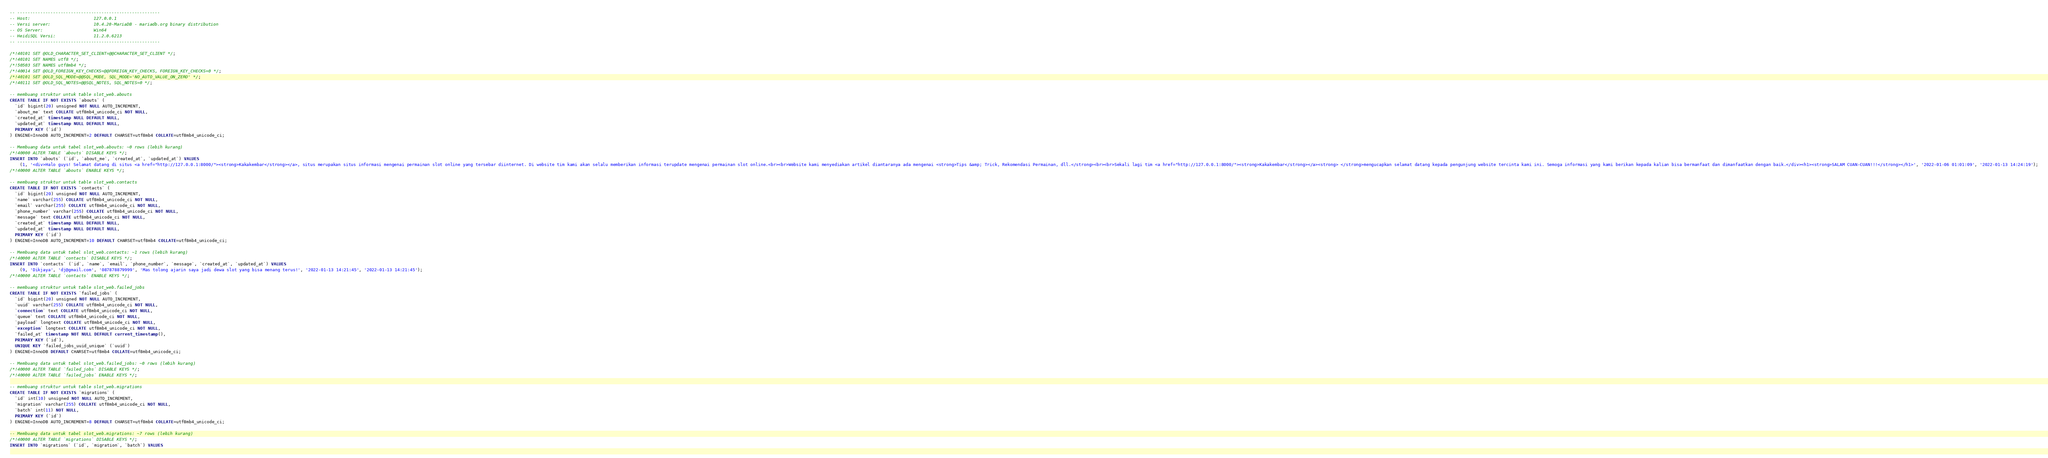<code> <loc_0><loc_0><loc_500><loc_500><_SQL_>-- --------------------------------------------------------
-- Host:                         127.0.0.1
-- Versi server:                 10.4.20-MariaDB - mariadb.org binary distribution
-- OS Server:                    Win64
-- HeidiSQL Versi:               11.2.0.6213
-- --------------------------------------------------------

/*!40101 SET @OLD_CHARACTER_SET_CLIENT=@@CHARACTER_SET_CLIENT */;
/*!40101 SET NAMES utf8 */;
/*!50503 SET NAMES utf8mb4 */;
/*!40014 SET @OLD_FOREIGN_KEY_CHECKS=@@FOREIGN_KEY_CHECKS, FOREIGN_KEY_CHECKS=0 */;
/*!40101 SET @OLD_SQL_MODE=@@SQL_MODE, SQL_MODE='NO_AUTO_VALUE_ON_ZERO' */;
/*!40111 SET @OLD_SQL_NOTES=@@SQL_NOTES, SQL_NOTES=0 */;

-- membuang struktur untuk table slot_web.abouts
CREATE TABLE IF NOT EXISTS `abouts` (
  `id` bigint(20) unsigned NOT NULL AUTO_INCREMENT,
  `about_me` text COLLATE utf8mb4_unicode_ci NOT NULL,
  `created_at` timestamp NULL DEFAULT NULL,
  `updated_at` timestamp NULL DEFAULT NULL,
  PRIMARY KEY (`id`)
) ENGINE=InnoDB AUTO_INCREMENT=2 DEFAULT CHARSET=utf8mb4 COLLATE=utf8mb4_unicode_ci;

-- Membuang data untuk tabel slot_web.abouts: ~0 rows (lebih kurang)
/*!40000 ALTER TABLE `abouts` DISABLE KEYS */;
INSERT INTO `abouts` (`id`, `about_me`, `created_at`, `updated_at`) VALUES
	(1, '<div>Halo guys! Selamat datang di situs <a href="http://127.0.0.1:8000/"><strong>Kakakembar</strong></a>, situs merupakan situs informasi mengenai permainan slot online yang tersebar diinternet. Di website tim kami akan selalu memberikan informasi terupdate mengenai permainan slot online.<br><br>Website kami menyediakan artikel diantaranya ada mengenai <strong>Tips &amp; Trick, Rekomendasi Permainan, dll.</strong><br><br>Sekali lagi tim <a href="http://127.0.0.1:8000/"><strong>Kakakembar</strong></a><strong> </strong>mengucapkan selamat datang kepada pengunjung website tercinta kami ini. Semoga informasi yang kami berikan kepada kalian bisa bermanfaat dan dimanfaatkan dengan baik.</div><h1><strong>SALAM CUAN-CUAN!!!</strong></h1>', '2022-01-06 01:01:09', '2022-01-13 14:24:19');
/*!40000 ALTER TABLE `abouts` ENABLE KEYS */;

-- membuang struktur untuk table slot_web.contacts
CREATE TABLE IF NOT EXISTS `contacts` (
  `id` bigint(20) unsigned NOT NULL AUTO_INCREMENT,
  `name` varchar(255) COLLATE utf8mb4_unicode_ci NOT NULL,
  `email` varchar(255) COLLATE utf8mb4_unicode_ci NOT NULL,
  `phone_number` varchar(255) COLLATE utf8mb4_unicode_ci NOT NULL,
  `message` text COLLATE utf8mb4_unicode_ci NOT NULL,
  `created_at` timestamp NULL DEFAULT NULL,
  `updated_at` timestamp NULL DEFAULT NULL,
  PRIMARY KEY (`id`)
) ENGINE=InnoDB AUTO_INCREMENT=10 DEFAULT CHARSET=utf8mb4 COLLATE=utf8mb4_unicode_ci;

-- Membuang data untuk tabel slot_web.contacts: ~1 rows (lebih kurang)
/*!40000 ALTER TABLE `contacts` DISABLE KEYS */;
INSERT INTO `contacts` (`id`, `name`, `email`, `phone_number`, `message`, `created_at`, `updated_at`) VALUES
	(9, 'Dikjaya', 'dj@gmail.com', '087878879999', 'Mas tolong ajarin saya jadi dewa slot yang bisa menang terus!', '2022-01-13 14:21:45', '2022-01-13 14:21:45');
/*!40000 ALTER TABLE `contacts` ENABLE KEYS */;

-- membuang struktur untuk table slot_web.failed_jobs
CREATE TABLE IF NOT EXISTS `failed_jobs` (
  `id` bigint(20) unsigned NOT NULL AUTO_INCREMENT,
  `uuid` varchar(255) COLLATE utf8mb4_unicode_ci NOT NULL,
  `connection` text COLLATE utf8mb4_unicode_ci NOT NULL,
  `queue` text COLLATE utf8mb4_unicode_ci NOT NULL,
  `payload` longtext COLLATE utf8mb4_unicode_ci NOT NULL,
  `exception` longtext COLLATE utf8mb4_unicode_ci NOT NULL,
  `failed_at` timestamp NOT NULL DEFAULT current_timestamp(),
  PRIMARY KEY (`id`),
  UNIQUE KEY `failed_jobs_uuid_unique` (`uuid`)
) ENGINE=InnoDB DEFAULT CHARSET=utf8mb4 COLLATE=utf8mb4_unicode_ci;

-- Membuang data untuk tabel slot_web.failed_jobs: ~0 rows (lebih kurang)
/*!40000 ALTER TABLE `failed_jobs` DISABLE KEYS */;
/*!40000 ALTER TABLE `failed_jobs` ENABLE KEYS */;

-- membuang struktur untuk table slot_web.migrations
CREATE TABLE IF NOT EXISTS `migrations` (
  `id` int(10) unsigned NOT NULL AUTO_INCREMENT,
  `migration` varchar(255) COLLATE utf8mb4_unicode_ci NOT NULL,
  `batch` int(11) NOT NULL,
  PRIMARY KEY (`id`)
) ENGINE=InnoDB AUTO_INCREMENT=8 DEFAULT CHARSET=utf8mb4 COLLATE=utf8mb4_unicode_ci;

-- Membuang data untuk tabel slot_web.migrations: ~7 rows (lebih kurang)
/*!40000 ALTER TABLE `migrations` DISABLE KEYS */;
INSERT INTO `migrations` (`id`, `migration`, `batch`) VALUES</code> 